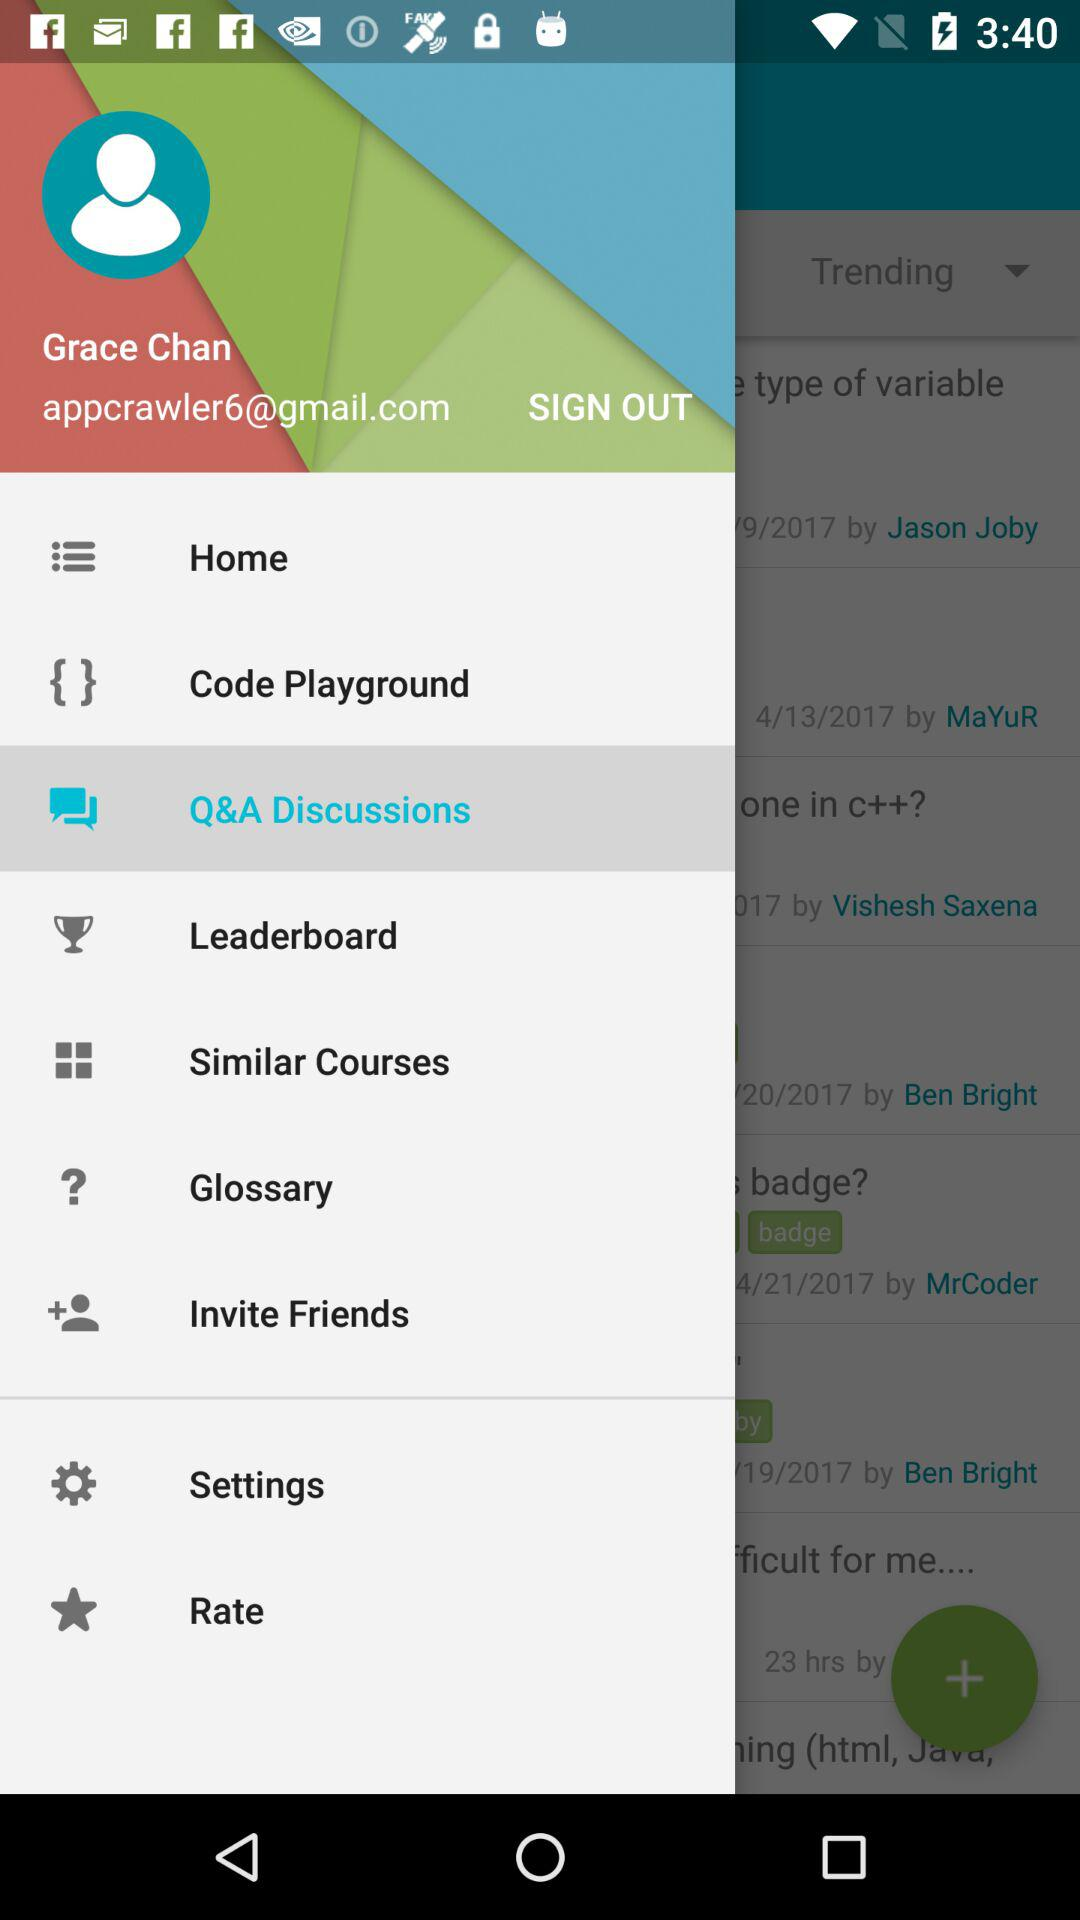What is the email address given? The email address given is appcrawler6@gmail.com. 